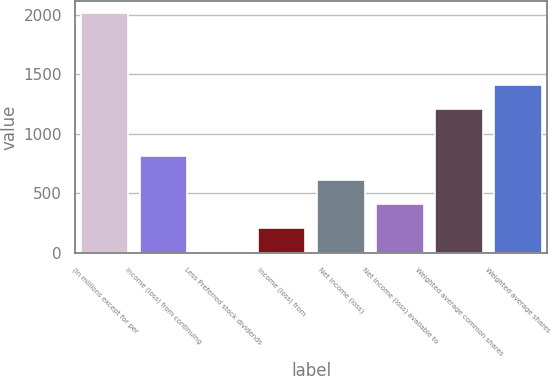<chart> <loc_0><loc_0><loc_500><loc_500><bar_chart><fcel>(In millions except for per<fcel>Income (loss) from continuing<fcel>Less Preferred stock dividends<fcel>Income (loss) from<fcel>Net income (loss)<fcel>Net income (loss) available to<fcel>Weighted average common shares<fcel>Weighted average shares<nl><fcel>2013<fcel>811.2<fcel>10<fcel>210.3<fcel>610.9<fcel>410.6<fcel>1211.8<fcel>1412.1<nl></chart> 